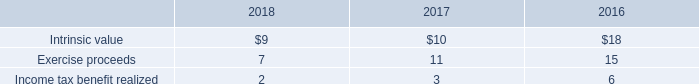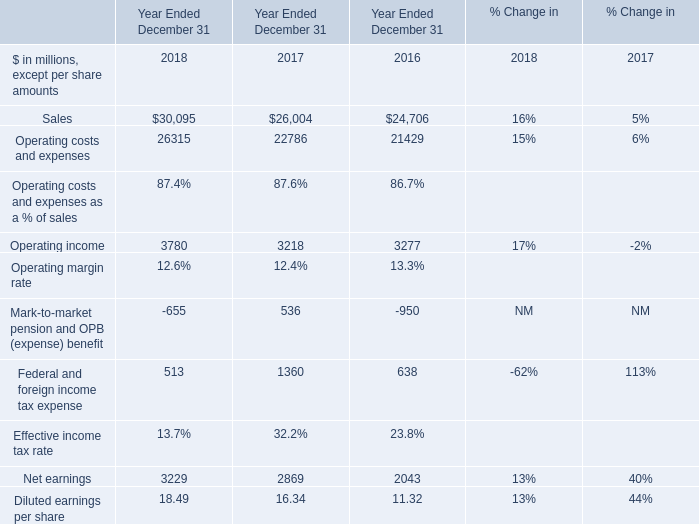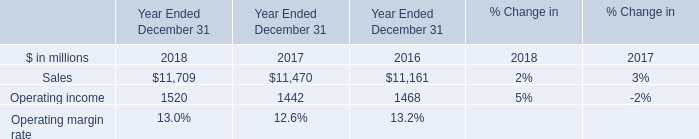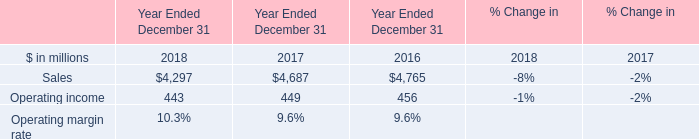What is the total amount of Sales of Year Ended December 31 2016, Sales of Year Ended December 31 2016, and Net earnings of Year Ended December 31 2018 ? 
Computations: ((4765.0 + 24706.0) + 3229.0)
Answer: 32700.0. 